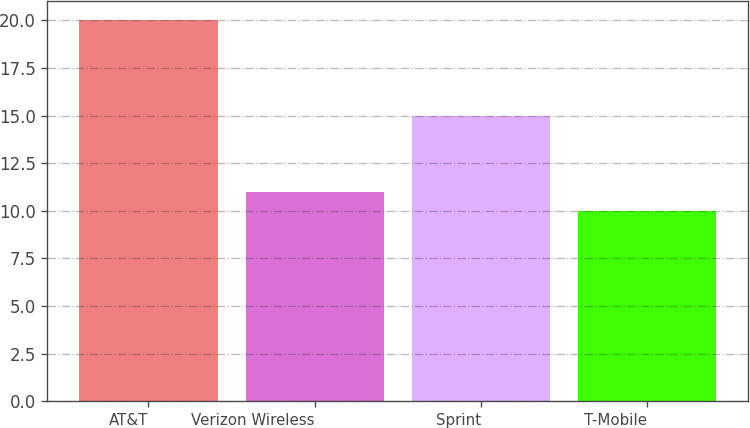Convert chart. <chart><loc_0><loc_0><loc_500><loc_500><bar_chart><fcel>AT&T<fcel>Verizon Wireless<fcel>Sprint<fcel>T-Mobile<nl><fcel>20<fcel>11<fcel>15<fcel>10<nl></chart> 